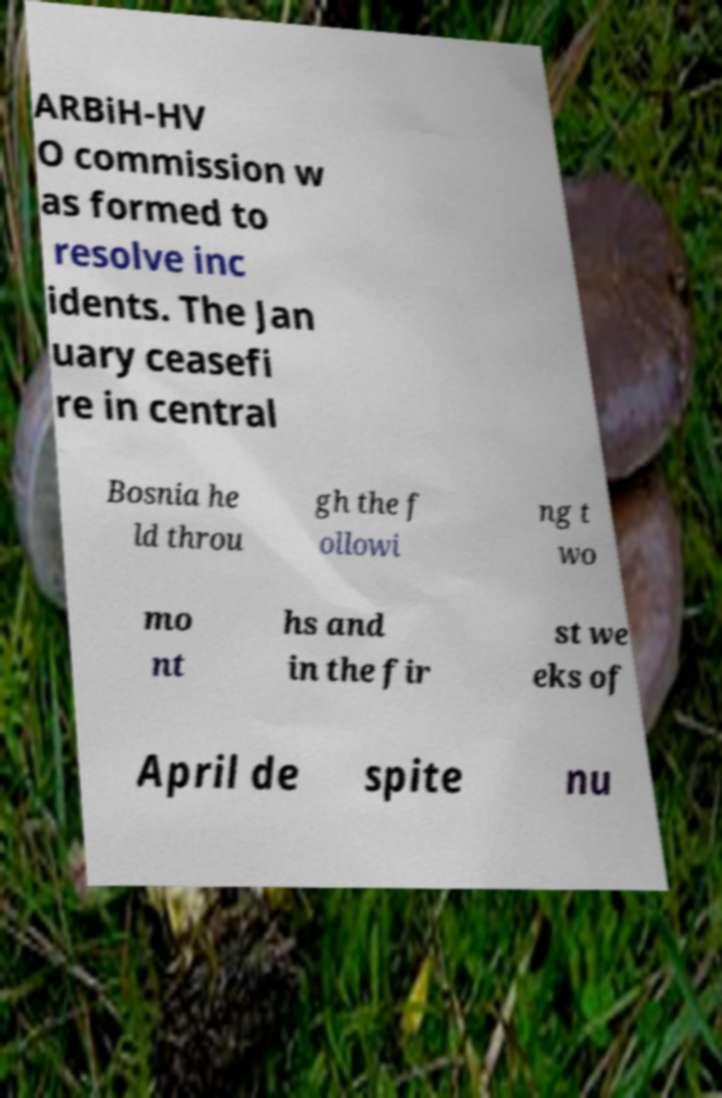What messages or text are displayed in this image? I need them in a readable, typed format. ARBiH-HV O commission w as formed to resolve inc idents. The Jan uary ceasefi re in central Bosnia he ld throu gh the f ollowi ng t wo mo nt hs and in the fir st we eks of April de spite nu 